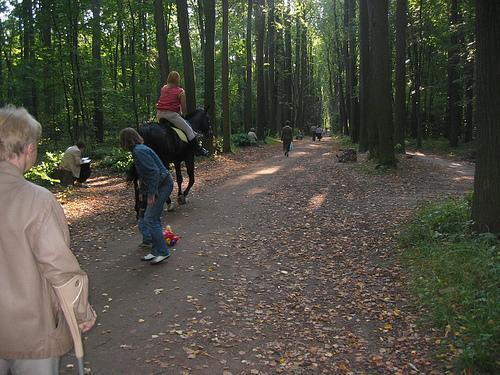How many people are in this picture?
Give a very brief answer. 8. How many people are in the photo?
Give a very brief answer. 2. How many pieces of cake are on this plate?
Give a very brief answer. 0. 